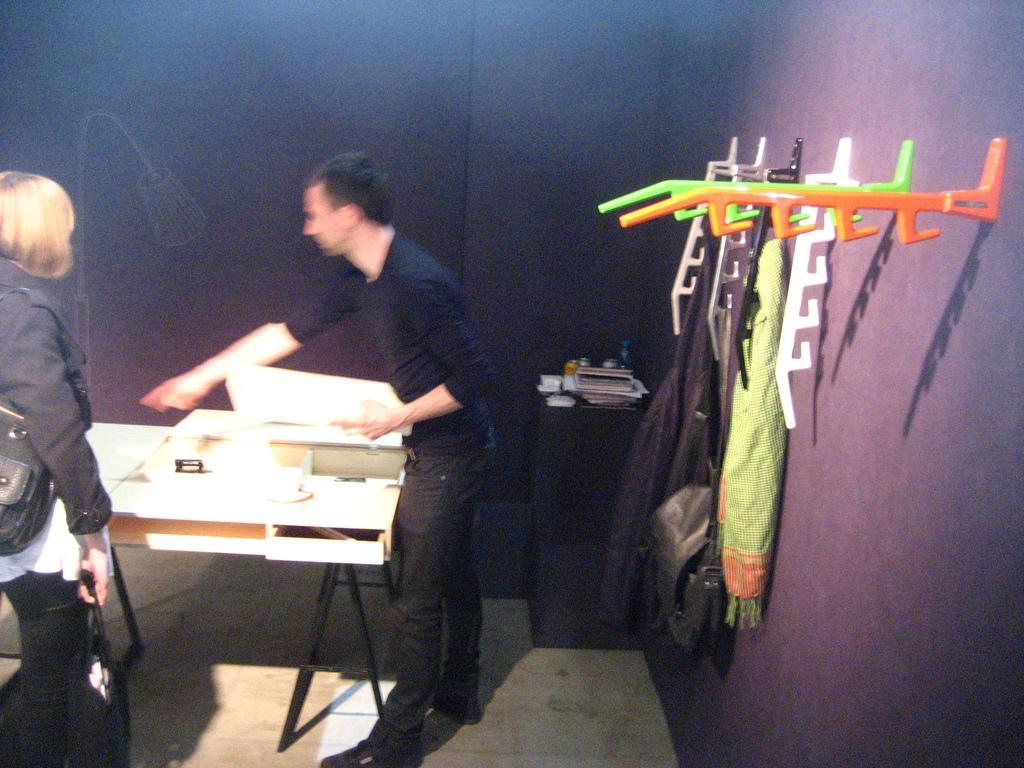Could you give a brief overview of what you see in this image? In the image in the center we can see one man is standing. And on the right side we can see hangers Along with some clothes. And coming to the left side we can see one lady is standing,she is holding one hand bag. And there is a table in front of her,on table we can see some objects. And coming to the background we can see the wall and few objects around them. 